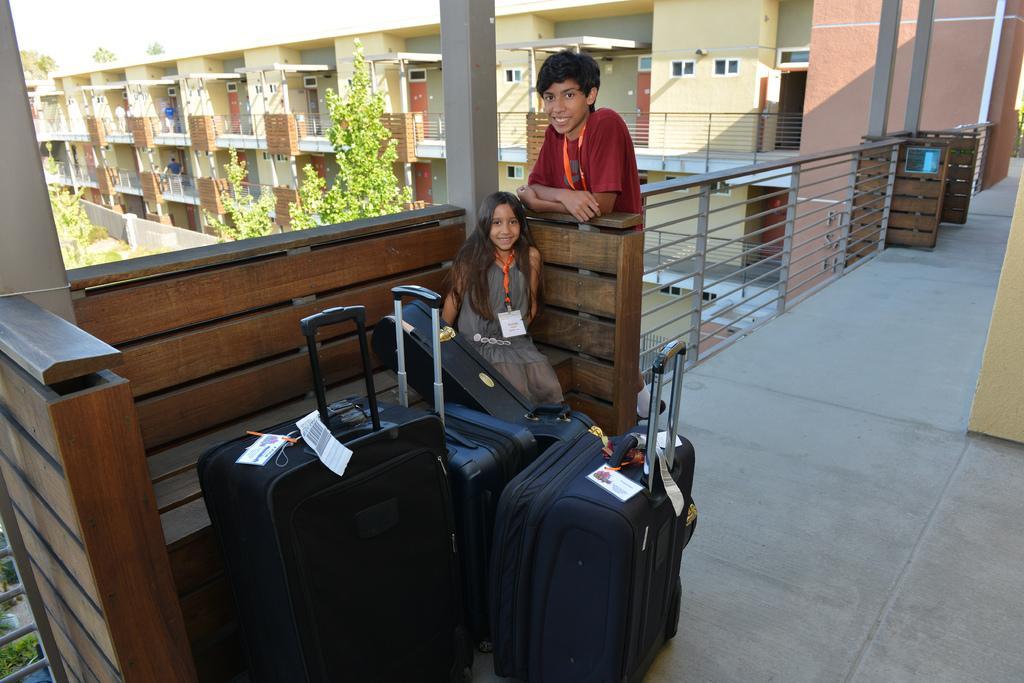Describe this image in one or two sentences. This picture is of inside. In the foreground we can see the bags placed on the ground and there is a girl sitting on the bench and a boy smiling and standing. In the background we can see the buildings and trees. 